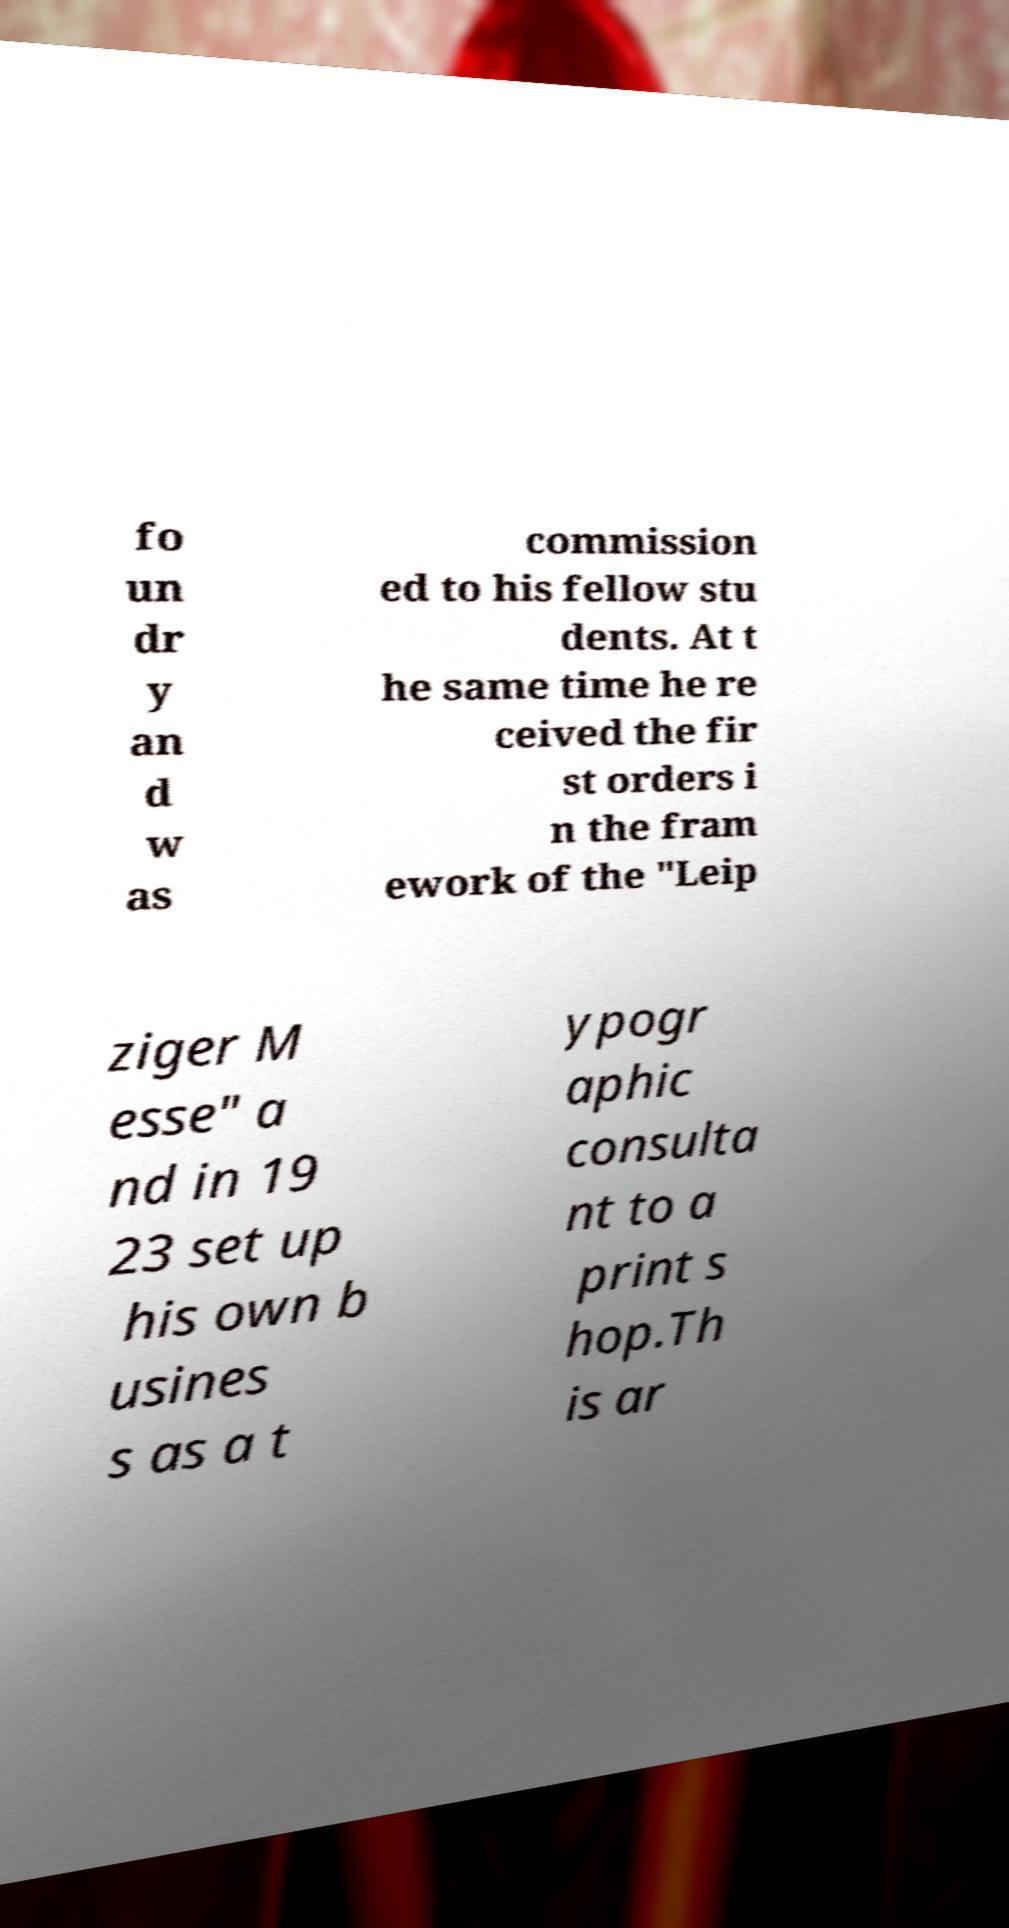Could you assist in decoding the text presented in this image and type it out clearly? fo un dr y an d w as commission ed to his fellow stu dents. At t he same time he re ceived the fir st orders i n the fram ework of the "Leip ziger M esse" a nd in 19 23 set up his own b usines s as a t ypogr aphic consulta nt to a print s hop.Th is ar 